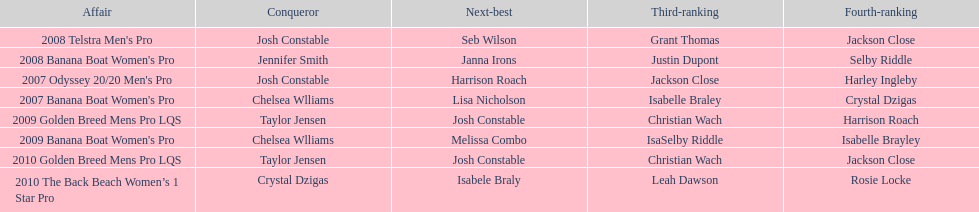How many times was josh constable second? 2. 